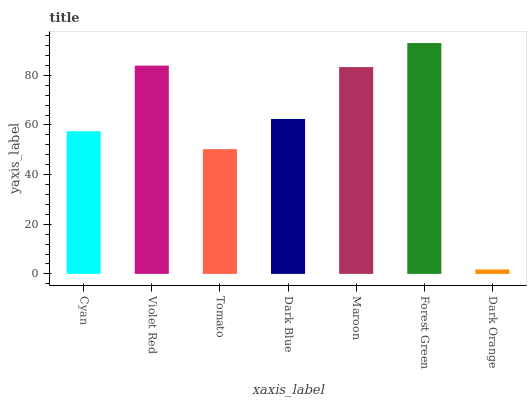Is Dark Orange the minimum?
Answer yes or no. Yes. Is Forest Green the maximum?
Answer yes or no. Yes. Is Violet Red the minimum?
Answer yes or no. No. Is Violet Red the maximum?
Answer yes or no. No. Is Violet Red greater than Cyan?
Answer yes or no. Yes. Is Cyan less than Violet Red?
Answer yes or no. Yes. Is Cyan greater than Violet Red?
Answer yes or no. No. Is Violet Red less than Cyan?
Answer yes or no. No. Is Dark Blue the high median?
Answer yes or no. Yes. Is Dark Blue the low median?
Answer yes or no. Yes. Is Cyan the high median?
Answer yes or no. No. Is Cyan the low median?
Answer yes or no. No. 